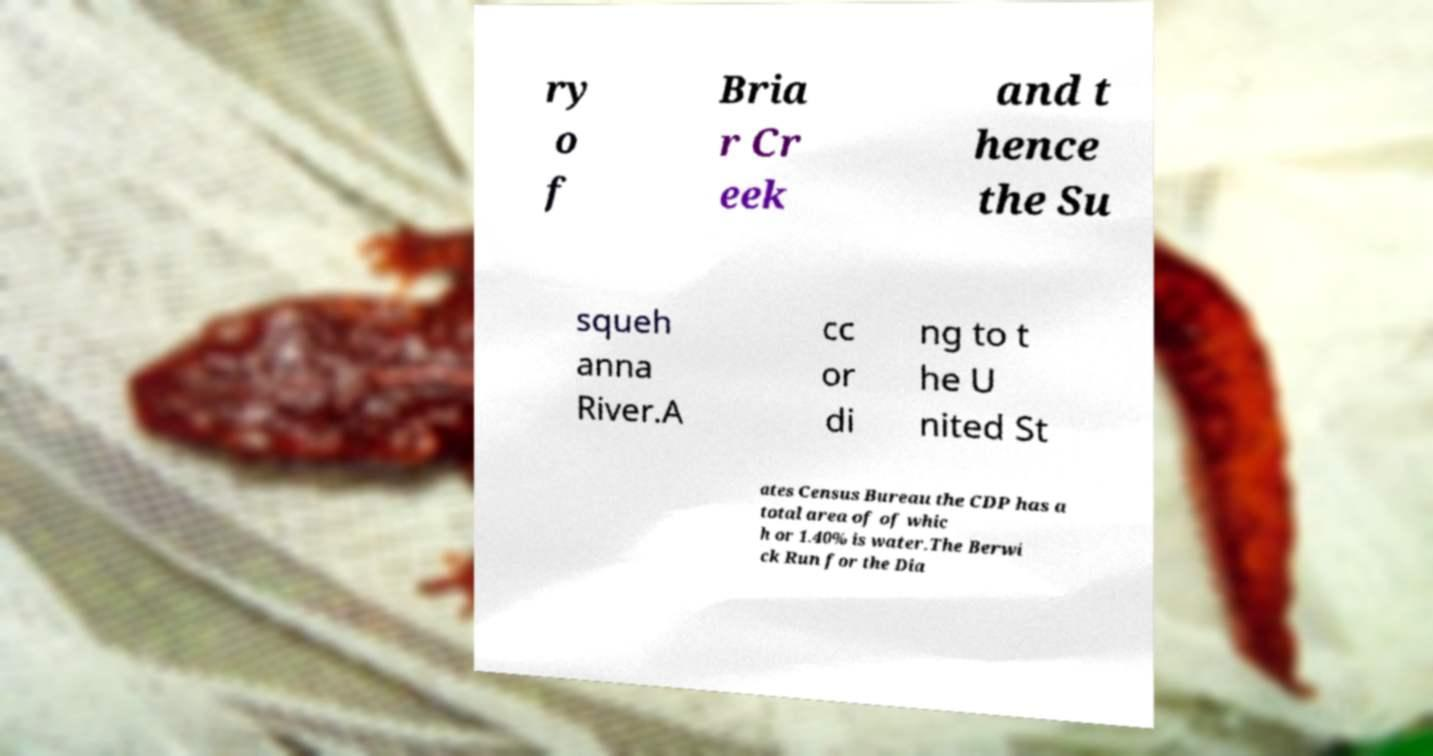Can you read and provide the text displayed in the image?This photo seems to have some interesting text. Can you extract and type it out for me? ry o f Bria r Cr eek and t hence the Su squeh anna River.A cc or di ng to t he U nited St ates Census Bureau the CDP has a total area of of whic h or 1.40% is water.The Berwi ck Run for the Dia 